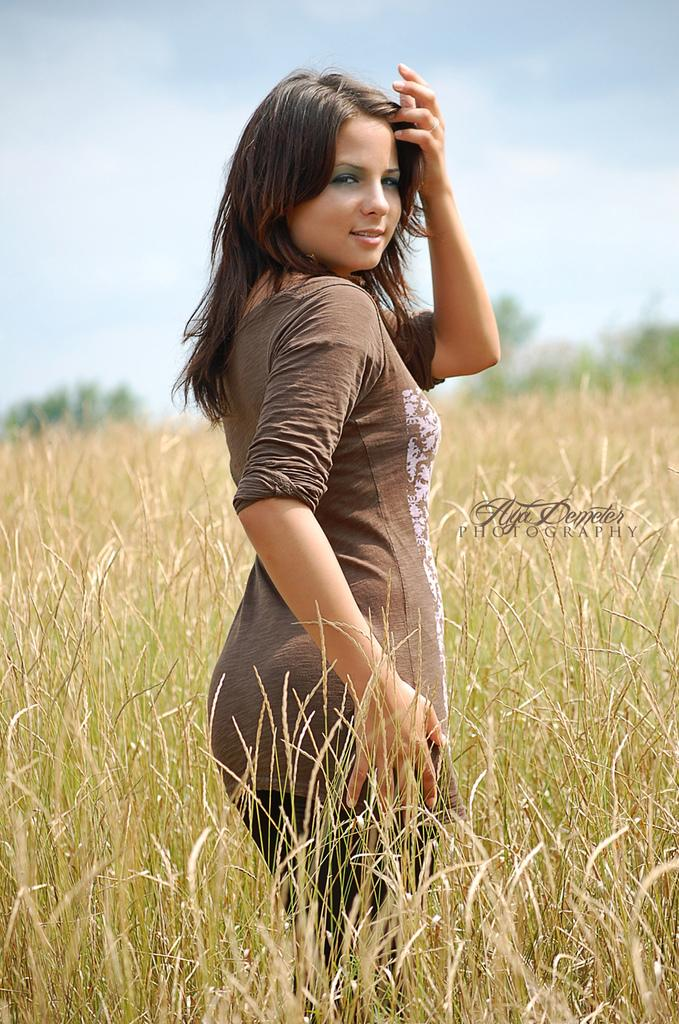Who is present in the image? There is a woman in the image. What is the woman standing on? The woman is standing in a grass plant area. What is the woman wearing? The woman is wearing a brown color T-shirt. What can be seen in the background of the image? There are trees and the sky visible in the background of the image. What is the condition of the sky in the image? Clouds are present in the sky. What type of glass is the woman holding in the image? There is no glass present in the image; the woman is standing in a grass plant area. Can you see any flames in the image? There are no flames present in the image; the sky has clouds in it. 